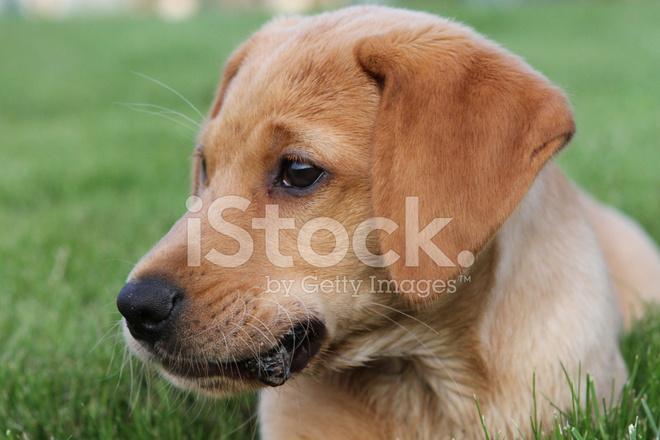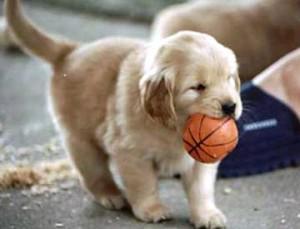The first image is the image on the left, the second image is the image on the right. Examine the images to the left and right. Is the description "A dog is carrying something in its mouth." accurate? Answer yes or no. Yes. The first image is the image on the left, the second image is the image on the right. For the images displayed, is the sentence "In one image in each pair an upright dog has something in its mouth." factually correct? Answer yes or no. Yes. 